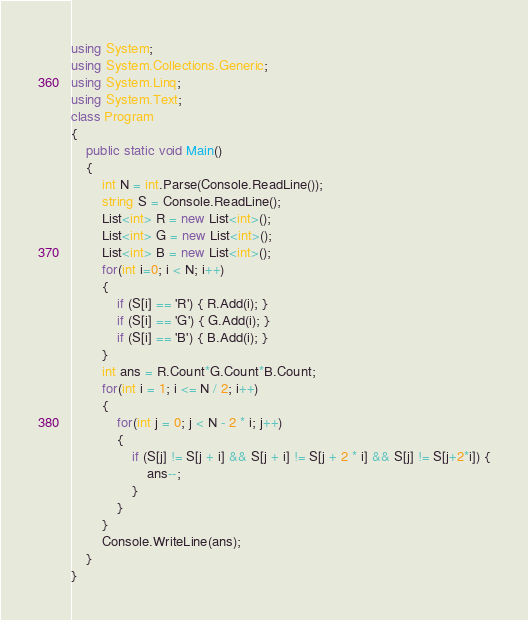Convert code to text. <code><loc_0><loc_0><loc_500><loc_500><_C#_>using System;
using System.Collections.Generic;
using System.Linq;
using System.Text;
class Program
{
    public static void Main()
    {
        int N = int.Parse(Console.ReadLine());
        string S = Console.ReadLine();
        List<int> R = new List<int>();
        List<int> G = new List<int>();
        List<int> B = new List<int>();
        for(int i=0; i < N; i++)
        {
            if (S[i] == 'R') { R.Add(i); }
            if (S[i] == 'G') { G.Add(i); }
            if (S[i] == 'B') { B.Add(i); }
        }
        int ans = R.Count*G.Count*B.Count;
        for(int i = 1; i <= N / 2; i++)
        {
            for(int j = 0; j < N - 2 * i; j++)
            {
                if (S[j] != S[j + i] && S[j + i] != S[j + 2 * i] && S[j] != S[j+2*i]) {
                    ans--;
                }
            }
        }
        Console.WriteLine(ans);
    }
}</code> 